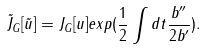<formula> <loc_0><loc_0><loc_500><loc_500>\tilde { J } _ { G } [ \tilde { u } ] = J _ { G } [ u ] e x p ( \frac { 1 } { 2 } \int d t \frac { b ^ { \prime \prime } } { 2 b ^ { \prime } } ) .</formula> 